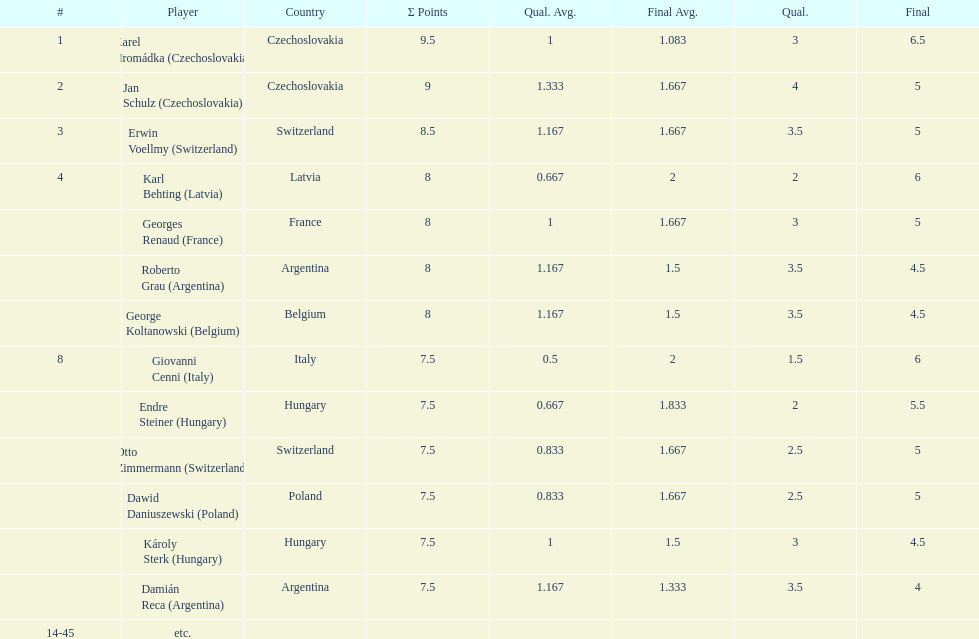Who was the top scorer from switzerland? Erwin Voellmy. 